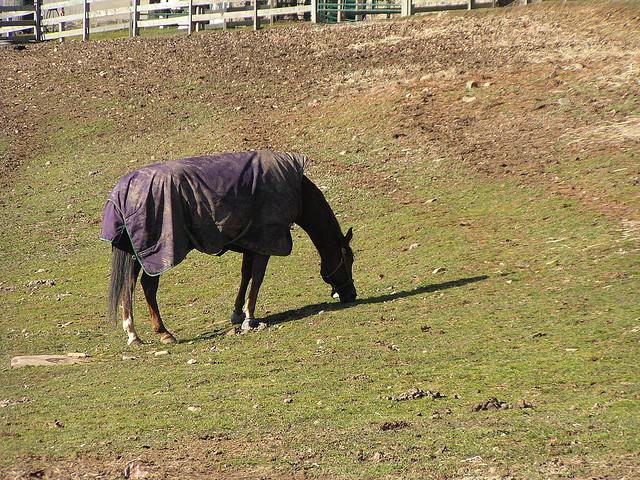How many colors are in the horse's mane?
Give a very brief answer. 1. How many horses are there in this picture?
Keep it brief. 1. What is on the horses back?
Short answer required. Blanket. What kind of grass is the horse eating?
Give a very brief answer. Green. How many horses are there?
Short answer required. 1. Is the horse being still?
Short answer required. Yes. What is the horse doing?
Concise answer only. Grazing. Are there any other animals in the picture?
Quick response, please. No. 